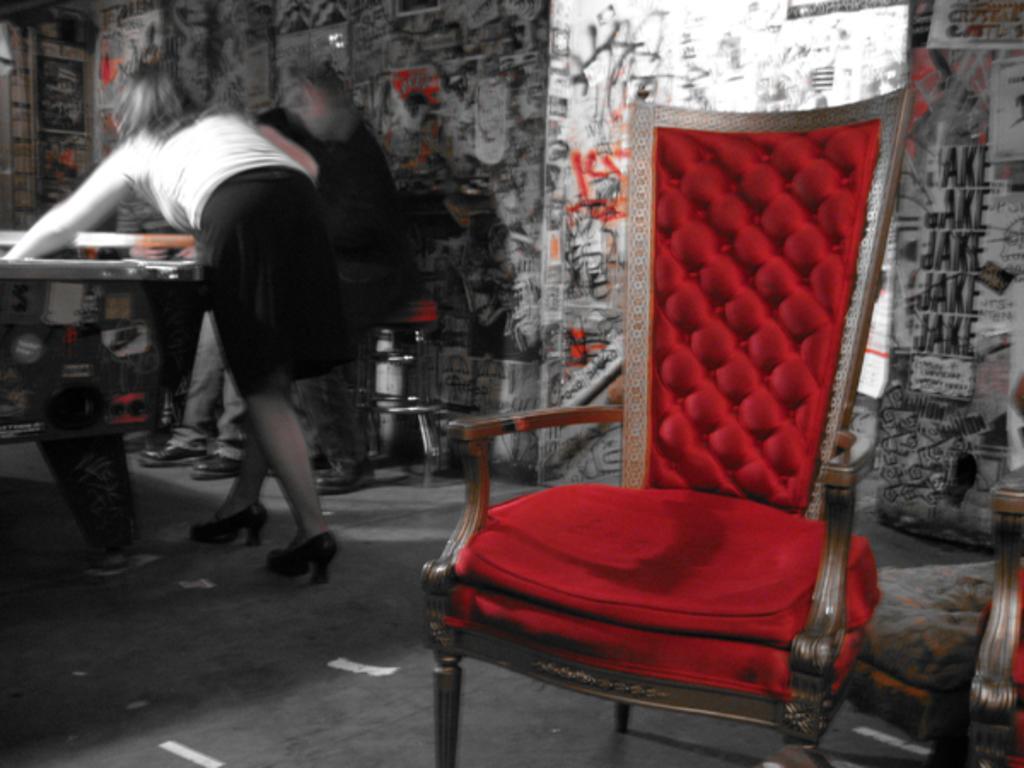In one or two sentences, can you explain what this image depicts? This is an edited image. In this image we can see some people standing beside a table. We can also see a chair, a lamp and a wall with some written text on it. 